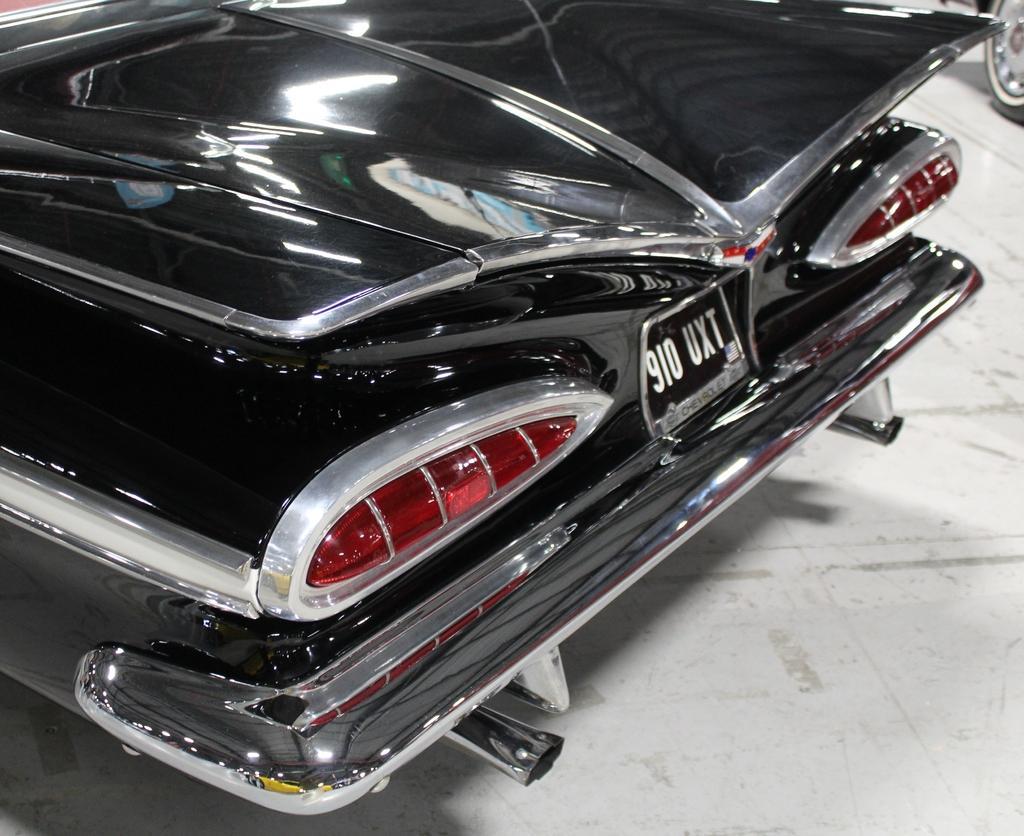How would you summarize this image in a sentence or two? In this image I can see it looks like a vehicle in black color. 